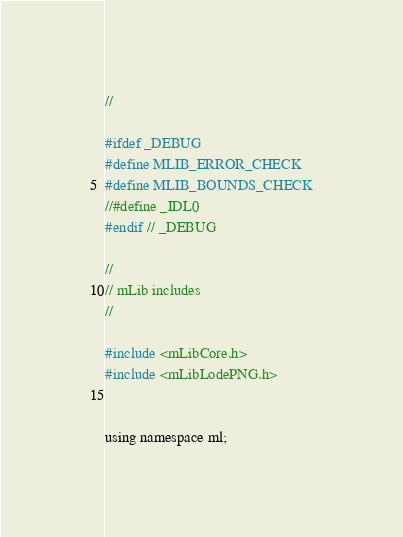Convert code to text. <code><loc_0><loc_0><loc_500><loc_500><_C_>//

#ifdef _DEBUG
#define MLIB_ERROR_CHECK
#define MLIB_BOUNDS_CHECK
//#define _IDL0
#endif // _DEBUG

//
// mLib includes
//

#include <mLibCore.h>
#include <mLibLodePNG.h>


using namespace ml;
</code> 